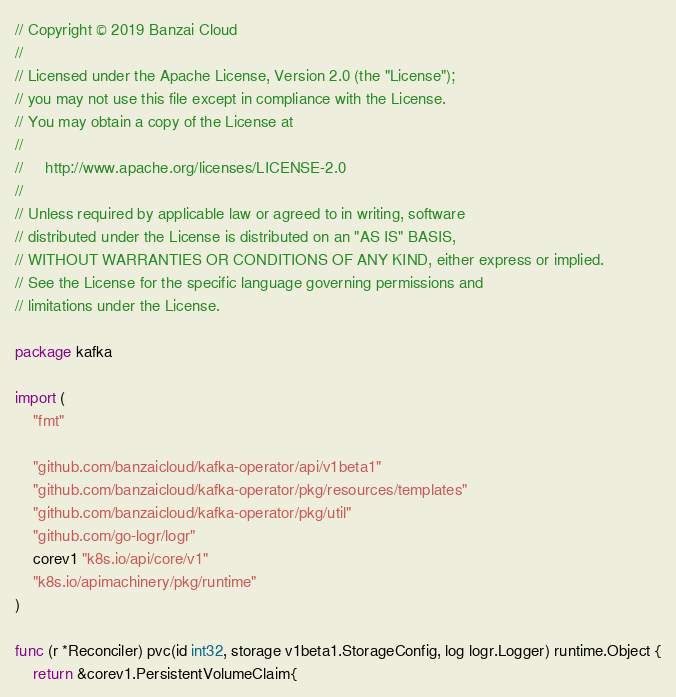<code> <loc_0><loc_0><loc_500><loc_500><_Go_>// Copyright © 2019 Banzai Cloud
//
// Licensed under the Apache License, Version 2.0 (the "License");
// you may not use this file except in compliance with the License.
// You may obtain a copy of the License at
//
//     http://www.apache.org/licenses/LICENSE-2.0
//
// Unless required by applicable law or agreed to in writing, software
// distributed under the License is distributed on an "AS IS" BASIS,
// WITHOUT WARRANTIES OR CONDITIONS OF ANY KIND, either express or implied.
// See the License for the specific language governing permissions and
// limitations under the License.

package kafka

import (
	"fmt"

	"github.com/banzaicloud/kafka-operator/api/v1beta1"
	"github.com/banzaicloud/kafka-operator/pkg/resources/templates"
	"github.com/banzaicloud/kafka-operator/pkg/util"
	"github.com/go-logr/logr"
	corev1 "k8s.io/api/core/v1"
	"k8s.io/apimachinery/pkg/runtime"
)

func (r *Reconciler) pvc(id int32, storage v1beta1.StorageConfig, log logr.Logger) runtime.Object {
	return &corev1.PersistentVolumeClaim{</code> 